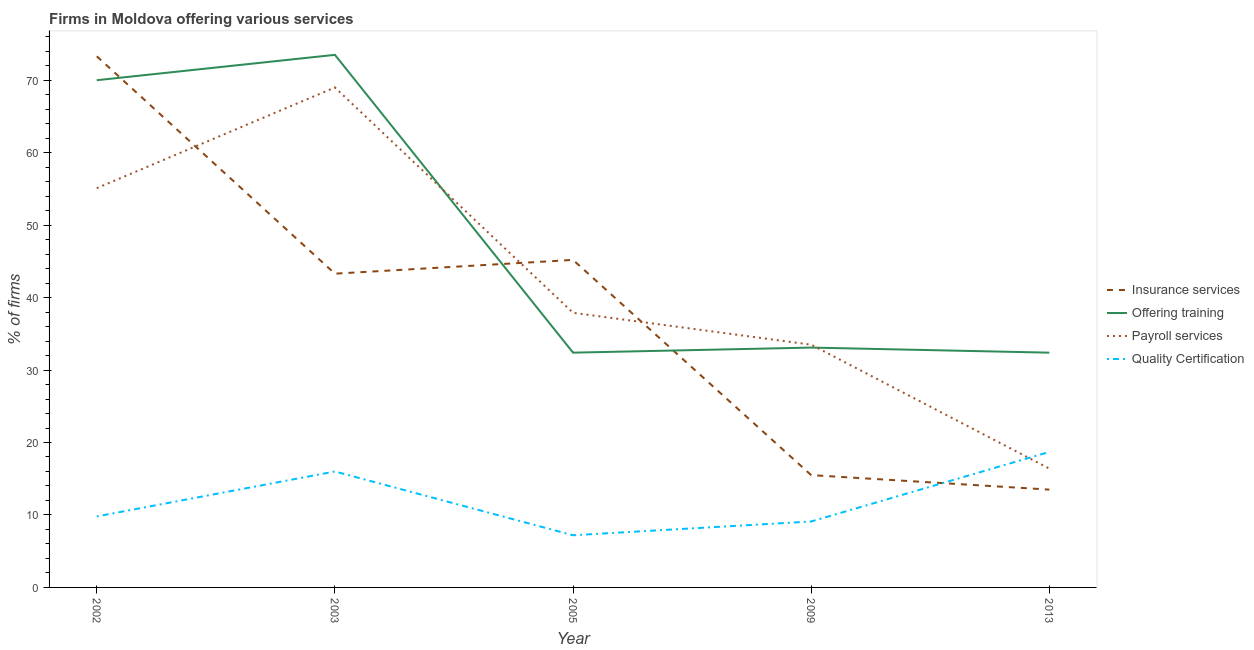How many different coloured lines are there?
Your answer should be very brief. 4. Is the number of lines equal to the number of legend labels?
Your answer should be compact. Yes. Across all years, what is the maximum percentage of firms offering insurance services?
Offer a very short reply. 73.3. Across all years, what is the minimum percentage of firms offering insurance services?
Give a very brief answer. 13.5. In which year was the percentage of firms offering training minimum?
Your response must be concise. 2005. What is the total percentage of firms offering insurance services in the graph?
Ensure brevity in your answer.  190.8. What is the difference between the percentage of firms offering quality certification in 2003 and that in 2005?
Give a very brief answer. 8.8. What is the difference between the percentage of firms offering payroll services in 2005 and the percentage of firms offering training in 2003?
Give a very brief answer. -35.6. What is the average percentage of firms offering insurance services per year?
Ensure brevity in your answer.  38.16. What is the ratio of the percentage of firms offering quality certification in 2002 to that in 2005?
Your answer should be very brief. 1.36. Is the percentage of firms offering quality certification in 2005 less than that in 2013?
Give a very brief answer. Yes. What is the difference between the highest and the second highest percentage of firms offering insurance services?
Offer a very short reply. 28.1. What is the difference between the highest and the lowest percentage of firms offering insurance services?
Keep it short and to the point. 59.8. In how many years, is the percentage of firms offering payroll services greater than the average percentage of firms offering payroll services taken over all years?
Give a very brief answer. 2. Is the sum of the percentage of firms offering insurance services in 2002 and 2003 greater than the maximum percentage of firms offering training across all years?
Provide a succinct answer. Yes. Is it the case that in every year, the sum of the percentage of firms offering insurance services and percentage of firms offering training is greater than the percentage of firms offering payroll services?
Provide a succinct answer. Yes. Does the percentage of firms offering payroll services monotonically increase over the years?
Offer a terse response. No. How many years are there in the graph?
Offer a very short reply. 5. What is the difference between two consecutive major ticks on the Y-axis?
Keep it short and to the point. 10. Are the values on the major ticks of Y-axis written in scientific E-notation?
Provide a succinct answer. No. What is the title of the graph?
Give a very brief answer. Firms in Moldova offering various services . What is the label or title of the X-axis?
Keep it short and to the point. Year. What is the label or title of the Y-axis?
Keep it short and to the point. % of firms. What is the % of firms in Insurance services in 2002?
Give a very brief answer. 73.3. What is the % of firms of Payroll services in 2002?
Your response must be concise. 55.1. What is the % of firms in Quality Certification in 2002?
Provide a short and direct response. 9.8. What is the % of firms in Insurance services in 2003?
Your answer should be very brief. 43.3. What is the % of firms of Offering training in 2003?
Offer a terse response. 73.5. What is the % of firms in Insurance services in 2005?
Your response must be concise. 45.2. What is the % of firms in Offering training in 2005?
Your answer should be very brief. 32.4. What is the % of firms of Payroll services in 2005?
Ensure brevity in your answer.  37.9. What is the % of firms in Insurance services in 2009?
Your response must be concise. 15.5. What is the % of firms in Offering training in 2009?
Your answer should be very brief. 33.1. What is the % of firms of Payroll services in 2009?
Offer a very short reply. 33.5. What is the % of firms of Offering training in 2013?
Offer a terse response. 32.4. Across all years, what is the maximum % of firms of Insurance services?
Give a very brief answer. 73.3. Across all years, what is the maximum % of firms of Offering training?
Your answer should be compact. 73.5. Across all years, what is the maximum % of firms of Payroll services?
Your answer should be very brief. 69. Across all years, what is the minimum % of firms in Insurance services?
Make the answer very short. 13.5. Across all years, what is the minimum % of firms in Offering training?
Make the answer very short. 32.4. Across all years, what is the minimum % of firms in Quality Certification?
Make the answer very short. 7.2. What is the total % of firms in Insurance services in the graph?
Your answer should be compact. 190.8. What is the total % of firms of Offering training in the graph?
Make the answer very short. 241.4. What is the total % of firms of Payroll services in the graph?
Keep it short and to the point. 211.9. What is the total % of firms in Quality Certification in the graph?
Your answer should be compact. 60.8. What is the difference between the % of firms of Offering training in 2002 and that in 2003?
Your answer should be very brief. -3.5. What is the difference between the % of firms of Payroll services in 2002 and that in 2003?
Your answer should be very brief. -13.9. What is the difference between the % of firms in Insurance services in 2002 and that in 2005?
Offer a very short reply. 28.1. What is the difference between the % of firms in Offering training in 2002 and that in 2005?
Ensure brevity in your answer.  37.6. What is the difference between the % of firms of Insurance services in 2002 and that in 2009?
Offer a very short reply. 57.8. What is the difference between the % of firms in Offering training in 2002 and that in 2009?
Your answer should be compact. 36.9. What is the difference between the % of firms in Payroll services in 2002 and that in 2009?
Offer a very short reply. 21.6. What is the difference between the % of firms of Quality Certification in 2002 and that in 2009?
Offer a very short reply. 0.7. What is the difference between the % of firms of Insurance services in 2002 and that in 2013?
Offer a terse response. 59.8. What is the difference between the % of firms in Offering training in 2002 and that in 2013?
Your response must be concise. 37.6. What is the difference between the % of firms of Payroll services in 2002 and that in 2013?
Your response must be concise. 38.7. What is the difference between the % of firms in Quality Certification in 2002 and that in 2013?
Make the answer very short. -8.9. What is the difference between the % of firms in Insurance services in 2003 and that in 2005?
Offer a terse response. -1.9. What is the difference between the % of firms in Offering training in 2003 and that in 2005?
Offer a terse response. 41.1. What is the difference between the % of firms in Payroll services in 2003 and that in 2005?
Ensure brevity in your answer.  31.1. What is the difference between the % of firms in Quality Certification in 2003 and that in 2005?
Keep it short and to the point. 8.8. What is the difference between the % of firms in Insurance services in 2003 and that in 2009?
Your answer should be very brief. 27.8. What is the difference between the % of firms of Offering training in 2003 and that in 2009?
Offer a terse response. 40.4. What is the difference between the % of firms of Payroll services in 2003 and that in 2009?
Ensure brevity in your answer.  35.5. What is the difference between the % of firms in Insurance services in 2003 and that in 2013?
Your answer should be very brief. 29.8. What is the difference between the % of firms of Offering training in 2003 and that in 2013?
Your answer should be compact. 41.1. What is the difference between the % of firms of Payroll services in 2003 and that in 2013?
Provide a short and direct response. 52.6. What is the difference between the % of firms of Insurance services in 2005 and that in 2009?
Provide a short and direct response. 29.7. What is the difference between the % of firms in Offering training in 2005 and that in 2009?
Keep it short and to the point. -0.7. What is the difference between the % of firms of Payroll services in 2005 and that in 2009?
Provide a short and direct response. 4.4. What is the difference between the % of firms in Insurance services in 2005 and that in 2013?
Your answer should be very brief. 31.7. What is the difference between the % of firms of Offering training in 2005 and that in 2013?
Offer a terse response. 0. What is the difference between the % of firms in Payroll services in 2005 and that in 2013?
Your response must be concise. 21.5. What is the difference between the % of firms in Insurance services in 2009 and that in 2013?
Provide a short and direct response. 2. What is the difference between the % of firms of Payroll services in 2009 and that in 2013?
Your response must be concise. 17.1. What is the difference between the % of firms in Quality Certification in 2009 and that in 2013?
Offer a very short reply. -9.6. What is the difference between the % of firms in Insurance services in 2002 and the % of firms in Offering training in 2003?
Your answer should be compact. -0.2. What is the difference between the % of firms in Insurance services in 2002 and the % of firms in Payroll services in 2003?
Offer a terse response. 4.3. What is the difference between the % of firms of Insurance services in 2002 and the % of firms of Quality Certification in 2003?
Offer a terse response. 57.3. What is the difference between the % of firms in Offering training in 2002 and the % of firms in Payroll services in 2003?
Keep it short and to the point. 1. What is the difference between the % of firms of Payroll services in 2002 and the % of firms of Quality Certification in 2003?
Offer a terse response. 39.1. What is the difference between the % of firms of Insurance services in 2002 and the % of firms of Offering training in 2005?
Your answer should be very brief. 40.9. What is the difference between the % of firms of Insurance services in 2002 and the % of firms of Payroll services in 2005?
Your answer should be very brief. 35.4. What is the difference between the % of firms in Insurance services in 2002 and the % of firms in Quality Certification in 2005?
Your answer should be very brief. 66.1. What is the difference between the % of firms in Offering training in 2002 and the % of firms in Payroll services in 2005?
Provide a short and direct response. 32.1. What is the difference between the % of firms of Offering training in 2002 and the % of firms of Quality Certification in 2005?
Your response must be concise. 62.8. What is the difference between the % of firms of Payroll services in 2002 and the % of firms of Quality Certification in 2005?
Keep it short and to the point. 47.9. What is the difference between the % of firms of Insurance services in 2002 and the % of firms of Offering training in 2009?
Provide a short and direct response. 40.2. What is the difference between the % of firms of Insurance services in 2002 and the % of firms of Payroll services in 2009?
Give a very brief answer. 39.8. What is the difference between the % of firms of Insurance services in 2002 and the % of firms of Quality Certification in 2009?
Offer a terse response. 64.2. What is the difference between the % of firms in Offering training in 2002 and the % of firms in Payroll services in 2009?
Your answer should be compact. 36.5. What is the difference between the % of firms of Offering training in 2002 and the % of firms of Quality Certification in 2009?
Your answer should be very brief. 60.9. What is the difference between the % of firms of Payroll services in 2002 and the % of firms of Quality Certification in 2009?
Provide a succinct answer. 46. What is the difference between the % of firms in Insurance services in 2002 and the % of firms in Offering training in 2013?
Your answer should be very brief. 40.9. What is the difference between the % of firms of Insurance services in 2002 and the % of firms of Payroll services in 2013?
Your answer should be compact. 56.9. What is the difference between the % of firms of Insurance services in 2002 and the % of firms of Quality Certification in 2013?
Your answer should be compact. 54.6. What is the difference between the % of firms of Offering training in 2002 and the % of firms of Payroll services in 2013?
Keep it short and to the point. 53.6. What is the difference between the % of firms of Offering training in 2002 and the % of firms of Quality Certification in 2013?
Give a very brief answer. 51.3. What is the difference between the % of firms of Payroll services in 2002 and the % of firms of Quality Certification in 2013?
Your answer should be compact. 36.4. What is the difference between the % of firms of Insurance services in 2003 and the % of firms of Payroll services in 2005?
Your answer should be compact. 5.4. What is the difference between the % of firms of Insurance services in 2003 and the % of firms of Quality Certification in 2005?
Your answer should be very brief. 36.1. What is the difference between the % of firms of Offering training in 2003 and the % of firms of Payroll services in 2005?
Offer a terse response. 35.6. What is the difference between the % of firms in Offering training in 2003 and the % of firms in Quality Certification in 2005?
Give a very brief answer. 66.3. What is the difference between the % of firms in Payroll services in 2003 and the % of firms in Quality Certification in 2005?
Your answer should be compact. 61.8. What is the difference between the % of firms in Insurance services in 2003 and the % of firms in Offering training in 2009?
Make the answer very short. 10.2. What is the difference between the % of firms of Insurance services in 2003 and the % of firms of Payroll services in 2009?
Make the answer very short. 9.8. What is the difference between the % of firms in Insurance services in 2003 and the % of firms in Quality Certification in 2009?
Give a very brief answer. 34.2. What is the difference between the % of firms of Offering training in 2003 and the % of firms of Quality Certification in 2009?
Provide a succinct answer. 64.4. What is the difference between the % of firms in Payroll services in 2003 and the % of firms in Quality Certification in 2009?
Provide a succinct answer. 59.9. What is the difference between the % of firms in Insurance services in 2003 and the % of firms in Payroll services in 2013?
Your answer should be very brief. 26.9. What is the difference between the % of firms of Insurance services in 2003 and the % of firms of Quality Certification in 2013?
Provide a short and direct response. 24.6. What is the difference between the % of firms in Offering training in 2003 and the % of firms in Payroll services in 2013?
Make the answer very short. 57.1. What is the difference between the % of firms of Offering training in 2003 and the % of firms of Quality Certification in 2013?
Make the answer very short. 54.8. What is the difference between the % of firms of Payroll services in 2003 and the % of firms of Quality Certification in 2013?
Keep it short and to the point. 50.3. What is the difference between the % of firms in Insurance services in 2005 and the % of firms in Offering training in 2009?
Your answer should be compact. 12.1. What is the difference between the % of firms in Insurance services in 2005 and the % of firms in Payroll services in 2009?
Offer a very short reply. 11.7. What is the difference between the % of firms in Insurance services in 2005 and the % of firms in Quality Certification in 2009?
Give a very brief answer. 36.1. What is the difference between the % of firms of Offering training in 2005 and the % of firms of Quality Certification in 2009?
Keep it short and to the point. 23.3. What is the difference between the % of firms of Payroll services in 2005 and the % of firms of Quality Certification in 2009?
Provide a succinct answer. 28.8. What is the difference between the % of firms of Insurance services in 2005 and the % of firms of Offering training in 2013?
Provide a succinct answer. 12.8. What is the difference between the % of firms in Insurance services in 2005 and the % of firms in Payroll services in 2013?
Offer a terse response. 28.8. What is the difference between the % of firms in Insurance services in 2005 and the % of firms in Quality Certification in 2013?
Your response must be concise. 26.5. What is the difference between the % of firms in Offering training in 2005 and the % of firms in Payroll services in 2013?
Your answer should be compact. 16. What is the difference between the % of firms in Offering training in 2005 and the % of firms in Quality Certification in 2013?
Provide a short and direct response. 13.7. What is the difference between the % of firms of Insurance services in 2009 and the % of firms of Offering training in 2013?
Offer a very short reply. -16.9. What is the difference between the % of firms of Insurance services in 2009 and the % of firms of Payroll services in 2013?
Provide a short and direct response. -0.9. What is the difference between the % of firms of Insurance services in 2009 and the % of firms of Quality Certification in 2013?
Ensure brevity in your answer.  -3.2. What is the difference between the % of firms of Offering training in 2009 and the % of firms of Quality Certification in 2013?
Give a very brief answer. 14.4. What is the average % of firms of Insurance services per year?
Offer a terse response. 38.16. What is the average % of firms of Offering training per year?
Give a very brief answer. 48.28. What is the average % of firms of Payroll services per year?
Give a very brief answer. 42.38. What is the average % of firms of Quality Certification per year?
Provide a short and direct response. 12.16. In the year 2002, what is the difference between the % of firms in Insurance services and % of firms in Quality Certification?
Your answer should be very brief. 63.5. In the year 2002, what is the difference between the % of firms in Offering training and % of firms in Payroll services?
Provide a succinct answer. 14.9. In the year 2002, what is the difference between the % of firms in Offering training and % of firms in Quality Certification?
Offer a terse response. 60.2. In the year 2002, what is the difference between the % of firms in Payroll services and % of firms in Quality Certification?
Your response must be concise. 45.3. In the year 2003, what is the difference between the % of firms in Insurance services and % of firms in Offering training?
Ensure brevity in your answer.  -30.2. In the year 2003, what is the difference between the % of firms in Insurance services and % of firms in Payroll services?
Your answer should be compact. -25.7. In the year 2003, what is the difference between the % of firms of Insurance services and % of firms of Quality Certification?
Keep it short and to the point. 27.3. In the year 2003, what is the difference between the % of firms in Offering training and % of firms in Payroll services?
Offer a very short reply. 4.5. In the year 2003, what is the difference between the % of firms in Offering training and % of firms in Quality Certification?
Your answer should be very brief. 57.5. In the year 2003, what is the difference between the % of firms in Payroll services and % of firms in Quality Certification?
Provide a succinct answer. 53. In the year 2005, what is the difference between the % of firms of Insurance services and % of firms of Offering training?
Ensure brevity in your answer.  12.8. In the year 2005, what is the difference between the % of firms in Insurance services and % of firms in Quality Certification?
Your response must be concise. 38. In the year 2005, what is the difference between the % of firms in Offering training and % of firms in Quality Certification?
Offer a very short reply. 25.2. In the year 2005, what is the difference between the % of firms in Payroll services and % of firms in Quality Certification?
Make the answer very short. 30.7. In the year 2009, what is the difference between the % of firms in Insurance services and % of firms in Offering training?
Keep it short and to the point. -17.6. In the year 2009, what is the difference between the % of firms of Insurance services and % of firms of Payroll services?
Offer a very short reply. -18. In the year 2009, what is the difference between the % of firms of Offering training and % of firms of Payroll services?
Make the answer very short. -0.4. In the year 2009, what is the difference between the % of firms of Payroll services and % of firms of Quality Certification?
Your response must be concise. 24.4. In the year 2013, what is the difference between the % of firms in Insurance services and % of firms in Offering training?
Offer a very short reply. -18.9. In the year 2013, what is the difference between the % of firms of Insurance services and % of firms of Payroll services?
Provide a succinct answer. -2.9. In the year 2013, what is the difference between the % of firms in Offering training and % of firms in Payroll services?
Offer a very short reply. 16. In the year 2013, what is the difference between the % of firms in Payroll services and % of firms in Quality Certification?
Provide a short and direct response. -2.3. What is the ratio of the % of firms of Insurance services in 2002 to that in 2003?
Your answer should be very brief. 1.69. What is the ratio of the % of firms of Payroll services in 2002 to that in 2003?
Your answer should be very brief. 0.8. What is the ratio of the % of firms of Quality Certification in 2002 to that in 2003?
Your answer should be very brief. 0.61. What is the ratio of the % of firms of Insurance services in 2002 to that in 2005?
Offer a very short reply. 1.62. What is the ratio of the % of firms in Offering training in 2002 to that in 2005?
Your answer should be very brief. 2.16. What is the ratio of the % of firms in Payroll services in 2002 to that in 2005?
Offer a very short reply. 1.45. What is the ratio of the % of firms of Quality Certification in 2002 to that in 2005?
Make the answer very short. 1.36. What is the ratio of the % of firms in Insurance services in 2002 to that in 2009?
Give a very brief answer. 4.73. What is the ratio of the % of firms of Offering training in 2002 to that in 2009?
Make the answer very short. 2.11. What is the ratio of the % of firms in Payroll services in 2002 to that in 2009?
Your response must be concise. 1.64. What is the ratio of the % of firms of Insurance services in 2002 to that in 2013?
Keep it short and to the point. 5.43. What is the ratio of the % of firms in Offering training in 2002 to that in 2013?
Give a very brief answer. 2.16. What is the ratio of the % of firms in Payroll services in 2002 to that in 2013?
Your response must be concise. 3.36. What is the ratio of the % of firms in Quality Certification in 2002 to that in 2013?
Provide a succinct answer. 0.52. What is the ratio of the % of firms in Insurance services in 2003 to that in 2005?
Provide a short and direct response. 0.96. What is the ratio of the % of firms in Offering training in 2003 to that in 2005?
Your response must be concise. 2.27. What is the ratio of the % of firms of Payroll services in 2003 to that in 2005?
Keep it short and to the point. 1.82. What is the ratio of the % of firms of Quality Certification in 2003 to that in 2005?
Keep it short and to the point. 2.22. What is the ratio of the % of firms of Insurance services in 2003 to that in 2009?
Your response must be concise. 2.79. What is the ratio of the % of firms of Offering training in 2003 to that in 2009?
Offer a very short reply. 2.22. What is the ratio of the % of firms in Payroll services in 2003 to that in 2009?
Offer a very short reply. 2.06. What is the ratio of the % of firms in Quality Certification in 2003 to that in 2009?
Provide a succinct answer. 1.76. What is the ratio of the % of firms of Insurance services in 2003 to that in 2013?
Your answer should be very brief. 3.21. What is the ratio of the % of firms of Offering training in 2003 to that in 2013?
Your answer should be compact. 2.27. What is the ratio of the % of firms of Payroll services in 2003 to that in 2013?
Your response must be concise. 4.21. What is the ratio of the % of firms in Quality Certification in 2003 to that in 2013?
Ensure brevity in your answer.  0.86. What is the ratio of the % of firms in Insurance services in 2005 to that in 2009?
Your answer should be very brief. 2.92. What is the ratio of the % of firms of Offering training in 2005 to that in 2009?
Your response must be concise. 0.98. What is the ratio of the % of firms in Payroll services in 2005 to that in 2009?
Ensure brevity in your answer.  1.13. What is the ratio of the % of firms of Quality Certification in 2005 to that in 2009?
Provide a short and direct response. 0.79. What is the ratio of the % of firms of Insurance services in 2005 to that in 2013?
Your answer should be very brief. 3.35. What is the ratio of the % of firms in Payroll services in 2005 to that in 2013?
Make the answer very short. 2.31. What is the ratio of the % of firms in Quality Certification in 2005 to that in 2013?
Provide a succinct answer. 0.39. What is the ratio of the % of firms of Insurance services in 2009 to that in 2013?
Ensure brevity in your answer.  1.15. What is the ratio of the % of firms in Offering training in 2009 to that in 2013?
Make the answer very short. 1.02. What is the ratio of the % of firms of Payroll services in 2009 to that in 2013?
Give a very brief answer. 2.04. What is the ratio of the % of firms of Quality Certification in 2009 to that in 2013?
Ensure brevity in your answer.  0.49. What is the difference between the highest and the second highest % of firms in Insurance services?
Provide a short and direct response. 28.1. What is the difference between the highest and the second highest % of firms in Offering training?
Offer a terse response. 3.5. What is the difference between the highest and the lowest % of firms of Insurance services?
Your answer should be compact. 59.8. What is the difference between the highest and the lowest % of firms of Offering training?
Your response must be concise. 41.1. What is the difference between the highest and the lowest % of firms of Payroll services?
Provide a succinct answer. 52.6. What is the difference between the highest and the lowest % of firms in Quality Certification?
Your answer should be compact. 11.5. 